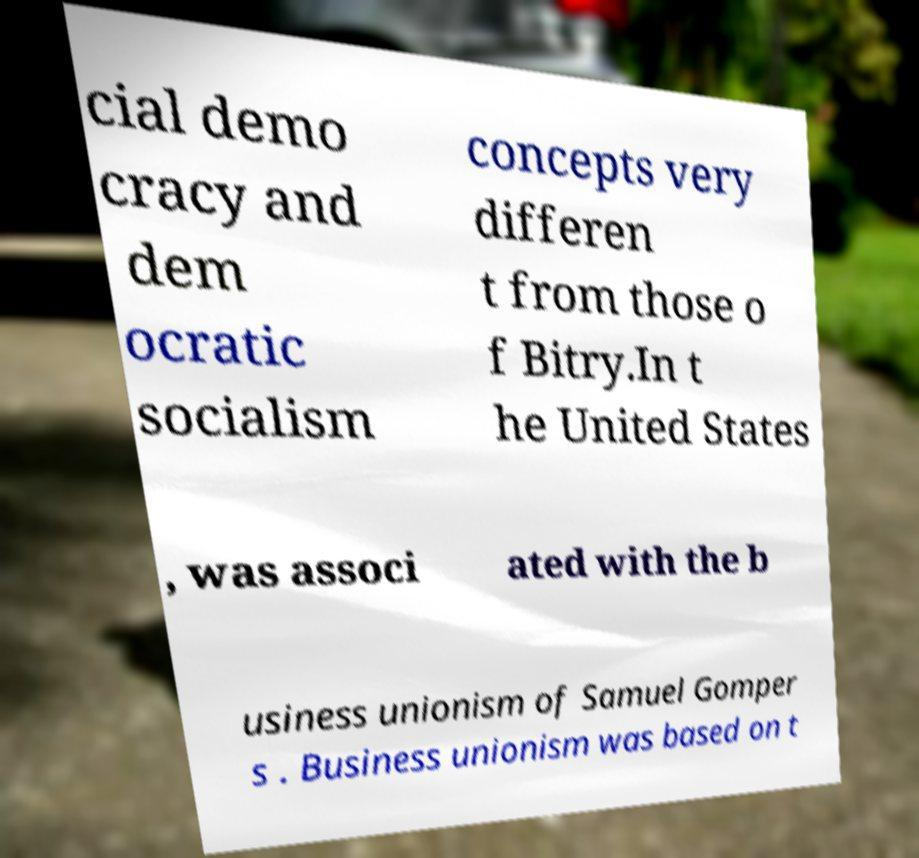Please identify and transcribe the text found in this image. cial demo cracy and dem ocratic socialism concepts very differen t from those o f Bitry.In t he United States , was associ ated with the b usiness unionism of Samuel Gomper s . Business unionism was based on t 